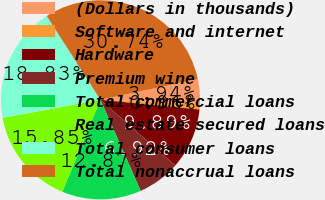<chart> <loc_0><loc_0><loc_500><loc_500><pie_chart><fcel>(Dollars in thousands)<fcel>Software and internet<fcel>Hardware<fcel>Premium wine<fcel>Total commercial loans<fcel>Real estate secured loans<fcel>Total consumer loans<fcel>Total nonaccrual loans<nl><fcel>3.94%<fcel>0.96%<fcel>9.89%<fcel>6.92%<fcel>12.87%<fcel>15.85%<fcel>18.83%<fcel>30.74%<nl></chart> 